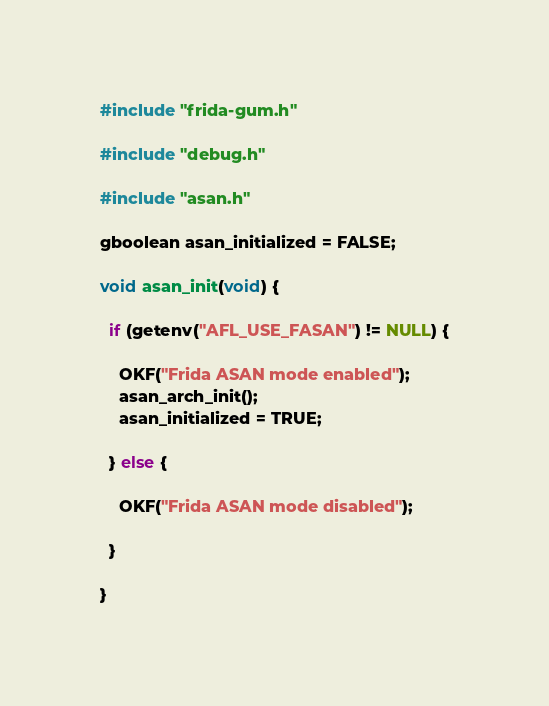Convert code to text. <code><loc_0><loc_0><loc_500><loc_500><_C_>#include "frida-gum.h"

#include "debug.h"

#include "asan.h"

gboolean asan_initialized = FALSE;

void asan_init(void) {

  if (getenv("AFL_USE_FASAN") != NULL) {

    OKF("Frida ASAN mode enabled");
    asan_arch_init();
    asan_initialized = TRUE;

  } else {

    OKF("Frida ASAN mode disabled");

  }

}

</code> 